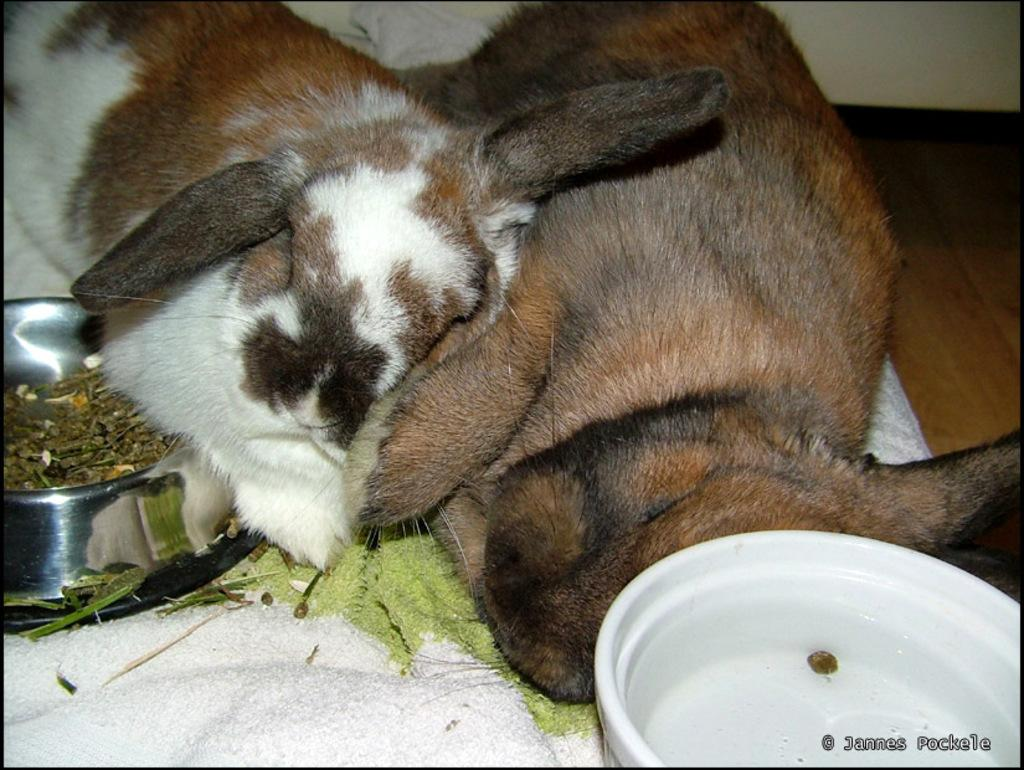What type of animal can be seen in the image? There is a dog in the image. What is the color of the mat in the image? The mat in the image is white. Where is the steel bowl located in the image? The steel bowl is on the left side of the image. What is the other bowl used for in the image? The other bowl on the right side of the image is likely used for food or water. What type of surface is visible in the image? There is a floor visible in the image. What is the background of the image? There is a wall in the image. How many thumbs does the dog have in the image? Dogs do not have thumbs, so this question cannot be answered based on the image. 